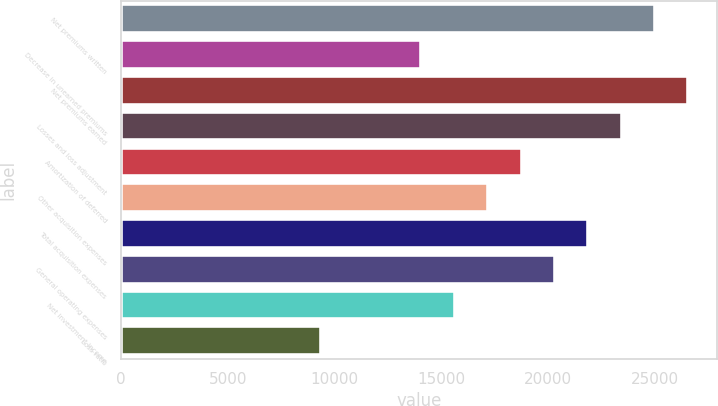Convert chart to OTSL. <chart><loc_0><loc_0><loc_500><loc_500><bar_chart><fcel>Net premiums written<fcel>Decrease in unearned premiums<fcel>Net premiums earned<fcel>Losses and loss adjustment<fcel>Amortization of deferred<fcel>Other acquisition expenses<fcel>Total acquisition expenses<fcel>General operating expenses<fcel>Net investment income<fcel>Loss ratio<nl><fcel>24994.6<fcel>14059.9<fcel>26556.7<fcel>23432.5<fcel>18746.2<fcel>17184.1<fcel>21870.4<fcel>20308.3<fcel>15622<fcel>9373.6<nl></chart> 